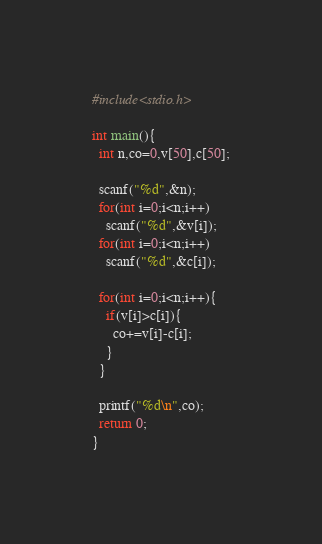<code> <loc_0><loc_0><loc_500><loc_500><_C_>#include<stdio.h>
 
int main(){
  int n,co=0,v[50],c[50];
  
  scanf("%d",&n);
  for(int i=0;i<n;i++)
    scanf("%d",&v[i]);
  for(int i=0;i<n;i++)    
    scanf("%d",&c[i]);
    
  for(int i=0;i<n;i++){
    if(v[i]>c[i]){
      co+=v[i]-c[i];
    }
  }
  
  printf("%d\n",co);
  return 0;
}</code> 